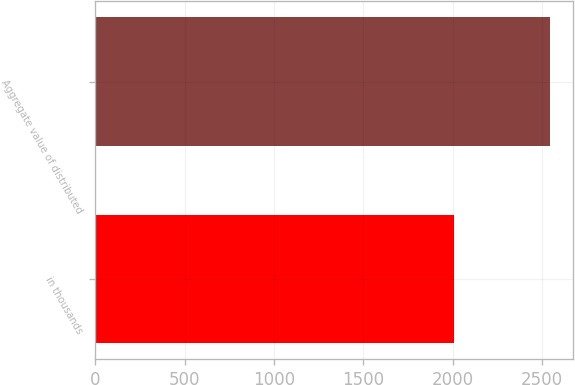Convert chart to OTSL. <chart><loc_0><loc_0><loc_500><loc_500><bar_chart><fcel>in thousands<fcel>Aggregate value of distributed<nl><fcel>2011<fcel>2548<nl></chart> 